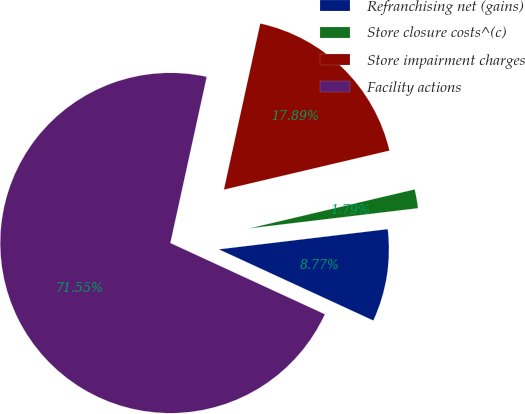<chart> <loc_0><loc_0><loc_500><loc_500><pie_chart><fcel>Refranchising net (gains)<fcel>Store closure costs^(c)<fcel>Store impairment charges<fcel>Facility actions<nl><fcel>8.77%<fcel>1.79%<fcel>17.89%<fcel>71.56%<nl></chart> 